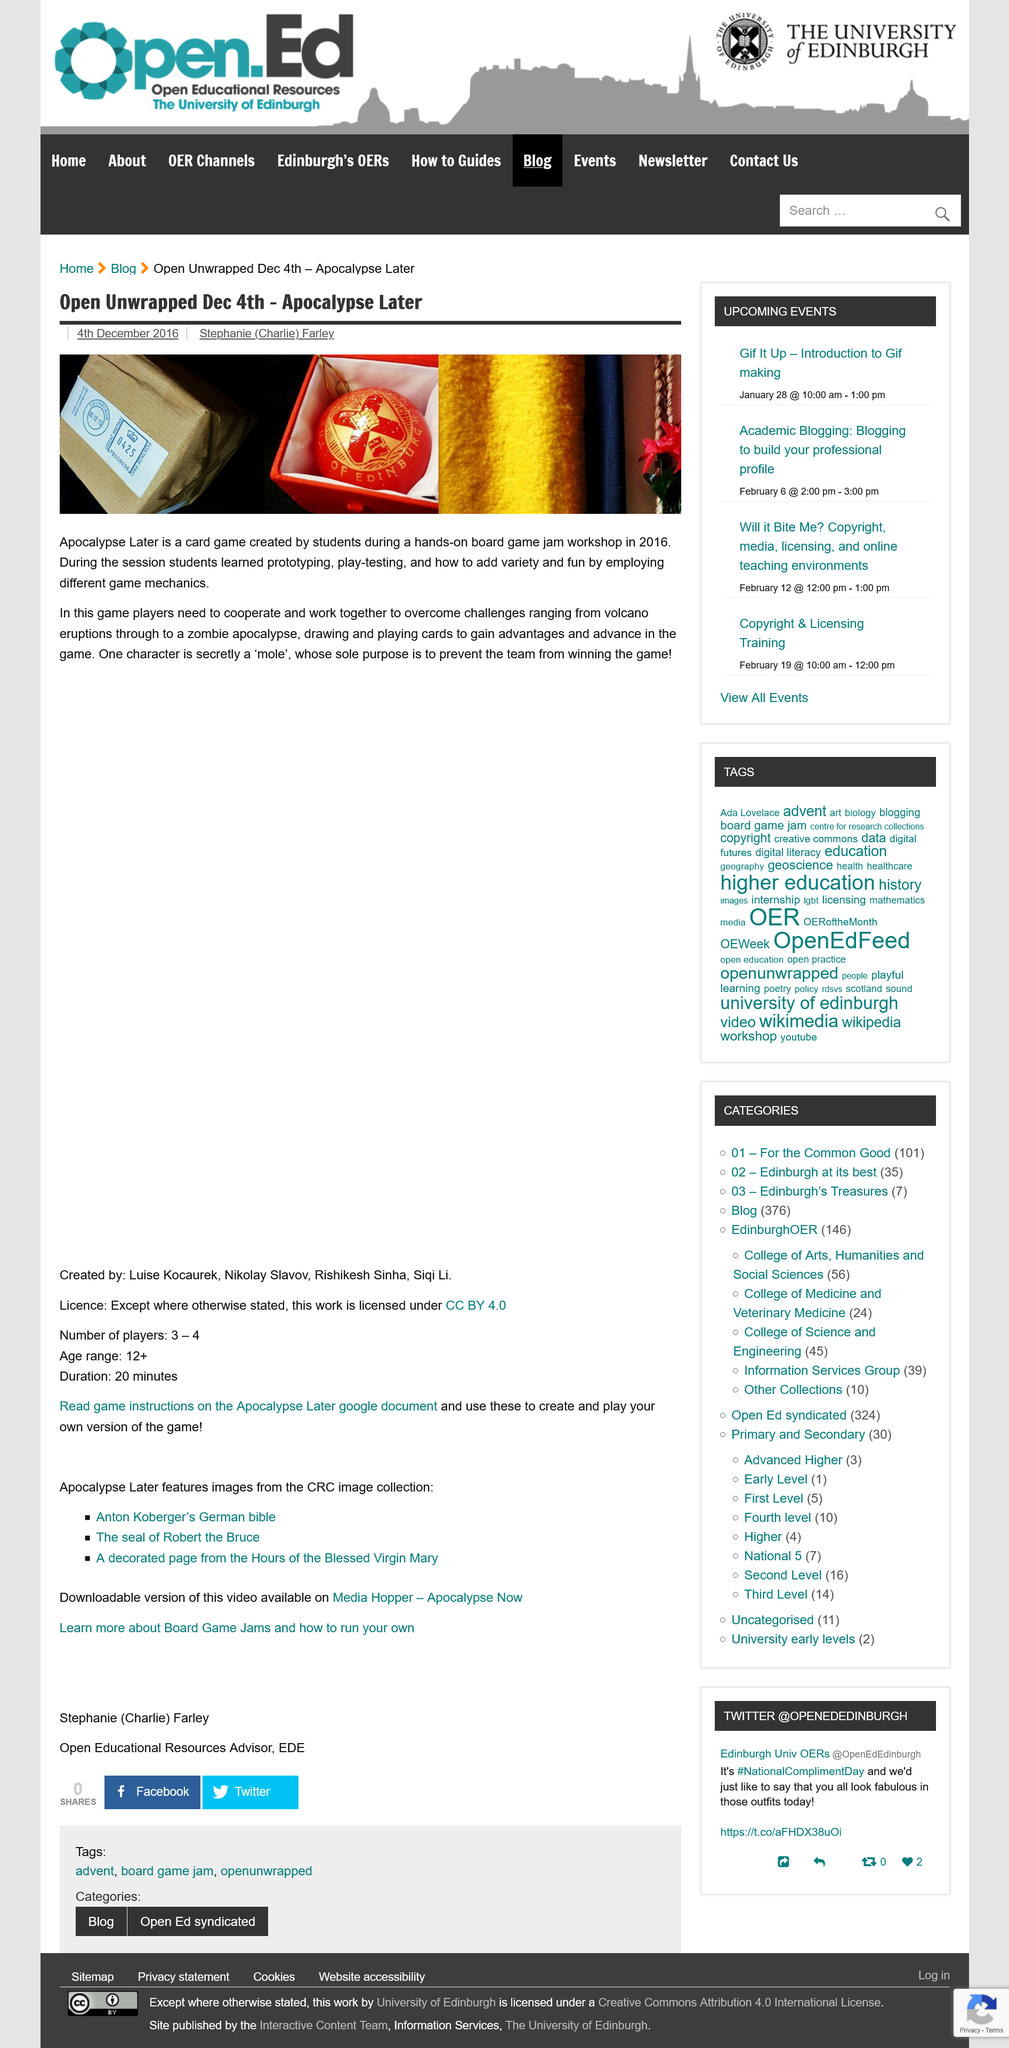Identify some key points in this picture. One character in the game of Apocolypse Later is a mole, secretly working for an opposing faction. Apocalypse Later was indeed created by students. Apocalypse Later is a card game, and it is a card game. 